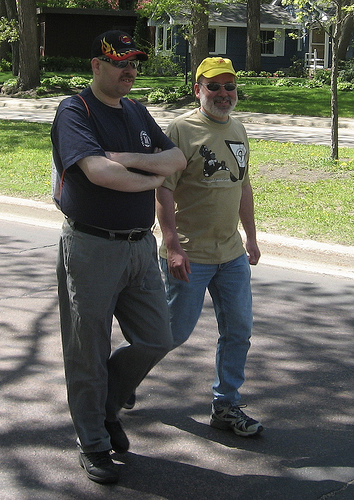<image>
Is the shoe on the road? Yes. Looking at the image, I can see the shoe is positioned on top of the road, with the road providing support. Is the belt on the grass? No. The belt is not positioned on the grass. They may be near each other, but the belt is not supported by or resting on top of the grass. Where is the house in relation to the man? Is it on the man? No. The house is not positioned on the man. They may be near each other, but the house is not supported by or resting on top of the man. Where is the man in relation to the man? Is it to the left of the man? Yes. From this viewpoint, the man is positioned to the left side relative to the man. Where is the men in relation to the road? Is it next to the road? No. The men is not positioned next to the road. They are located in different areas of the scene. 